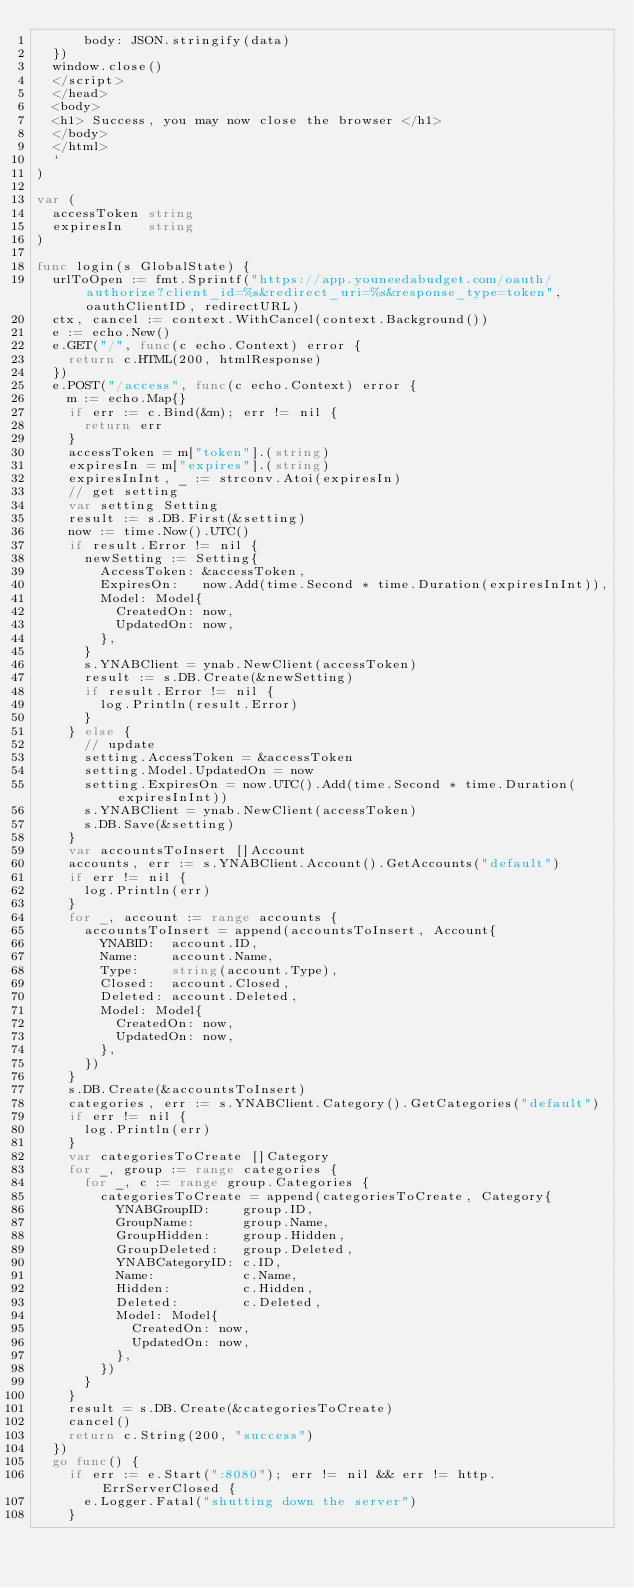<code> <loc_0><loc_0><loc_500><loc_500><_Go_>  		body: JSON.stringify(data)
	})
	window.close()
	</script>
	</head>
	<body>
	<h1> Success, you may now close the browser </h1>
	</body>
	</html>
	`
)

var (
	accessToken string
	expiresIn   string
)

func login(s GlobalState) {
	urlToOpen := fmt.Sprintf("https://app.youneedabudget.com/oauth/authorize?client_id=%s&redirect_uri=%s&response_type=token", oauthClientID, redirectURL)
	ctx, cancel := context.WithCancel(context.Background())
	e := echo.New()
	e.GET("/", func(c echo.Context) error {
		return c.HTML(200, htmlResponse)
	})
	e.POST("/access", func(c echo.Context) error {
		m := echo.Map{}
		if err := c.Bind(&m); err != nil {
			return err
		}
		accessToken = m["token"].(string)
		expiresIn = m["expires"].(string)
		expiresInInt, _ := strconv.Atoi(expiresIn)
		// get setting
		var setting Setting
		result := s.DB.First(&setting)
		now := time.Now().UTC()
		if result.Error != nil {
			newSetting := Setting{
				AccessToken: &accessToken,
				ExpiresOn:   now.Add(time.Second * time.Duration(expiresInInt)),
				Model: Model{
					CreatedOn: now,
					UpdatedOn: now,
				},
			}
			s.YNABClient = ynab.NewClient(accessToken)
			result := s.DB.Create(&newSetting)
			if result.Error != nil {
				log.Println(result.Error)
			}
		} else {
			// update
			setting.AccessToken = &accessToken
			setting.Model.UpdatedOn = now
			setting.ExpiresOn = now.UTC().Add(time.Second * time.Duration(expiresInInt))
			s.YNABClient = ynab.NewClient(accessToken)
			s.DB.Save(&setting)
		}
		var accountsToInsert []Account
		accounts, err := s.YNABClient.Account().GetAccounts("default")
		if err != nil {
			log.Println(err)
		}
		for _, account := range accounts {
			accountsToInsert = append(accountsToInsert, Account{
				YNABID:  account.ID,
				Name:    account.Name,
				Type:    string(account.Type),
				Closed:  account.Closed,
				Deleted: account.Deleted,
				Model: Model{
					CreatedOn: now,
					UpdatedOn: now,
				},
			})
		}
		s.DB.Create(&accountsToInsert)
		categories, err := s.YNABClient.Category().GetCategories("default")
		if err != nil {
			log.Println(err)
		}
		var categoriesToCreate []Category
		for _, group := range categories {
			for _, c := range group.Categories {
				categoriesToCreate = append(categoriesToCreate, Category{
					YNABGroupID:    group.ID,
					GroupName:      group.Name,
					GroupHidden:    group.Hidden,
					GroupDeleted:   group.Deleted,
					YNABCategoryID: c.ID,
					Name:           c.Name,
					Hidden:         c.Hidden,
					Deleted:        c.Deleted,
					Model: Model{
						CreatedOn: now,
						UpdatedOn: now,
					},
				})
			}
		}
		result = s.DB.Create(&categoriesToCreate)
		cancel()
		return c.String(200, "success")
	})
	go func() {
		if err := e.Start(":8080"); err != nil && err != http.ErrServerClosed {
			e.Logger.Fatal("shutting down the server")
		}</code> 